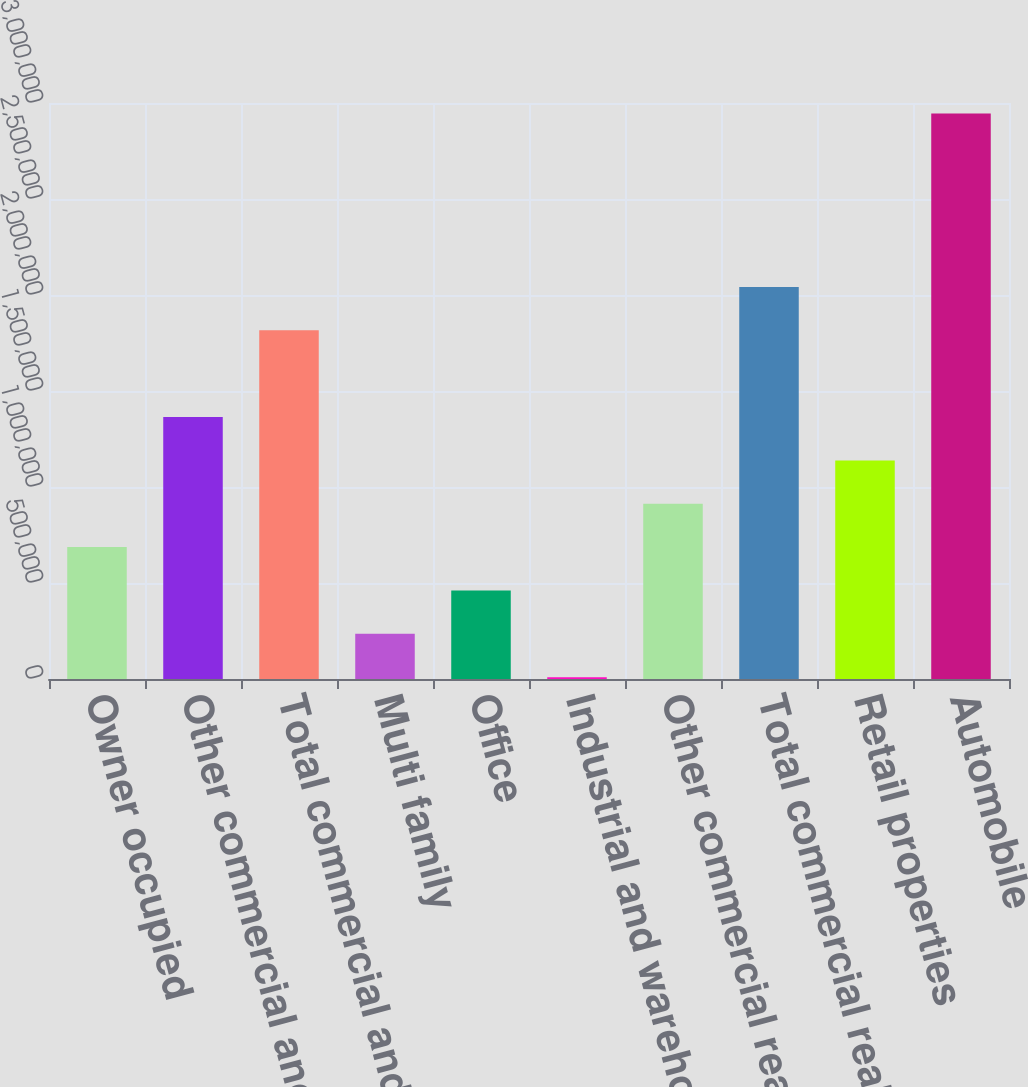Convert chart to OTSL. <chart><loc_0><loc_0><loc_500><loc_500><bar_chart><fcel>Owner occupied<fcel>Other commercial and<fcel>Total commercial and<fcel>Multi family<fcel>Office<fcel>Industrial and warehouse<fcel>Other commercial real estate<fcel>Total commercial real estate<fcel>Retail properties<fcel>Automobile<nl><fcel>686990<fcel>1.36429e+06<fcel>1.81583e+06<fcel>235456<fcel>461223<fcel>9688<fcel>912758<fcel>2.0416e+06<fcel>1.13853e+06<fcel>2.94467e+06<nl></chart> 